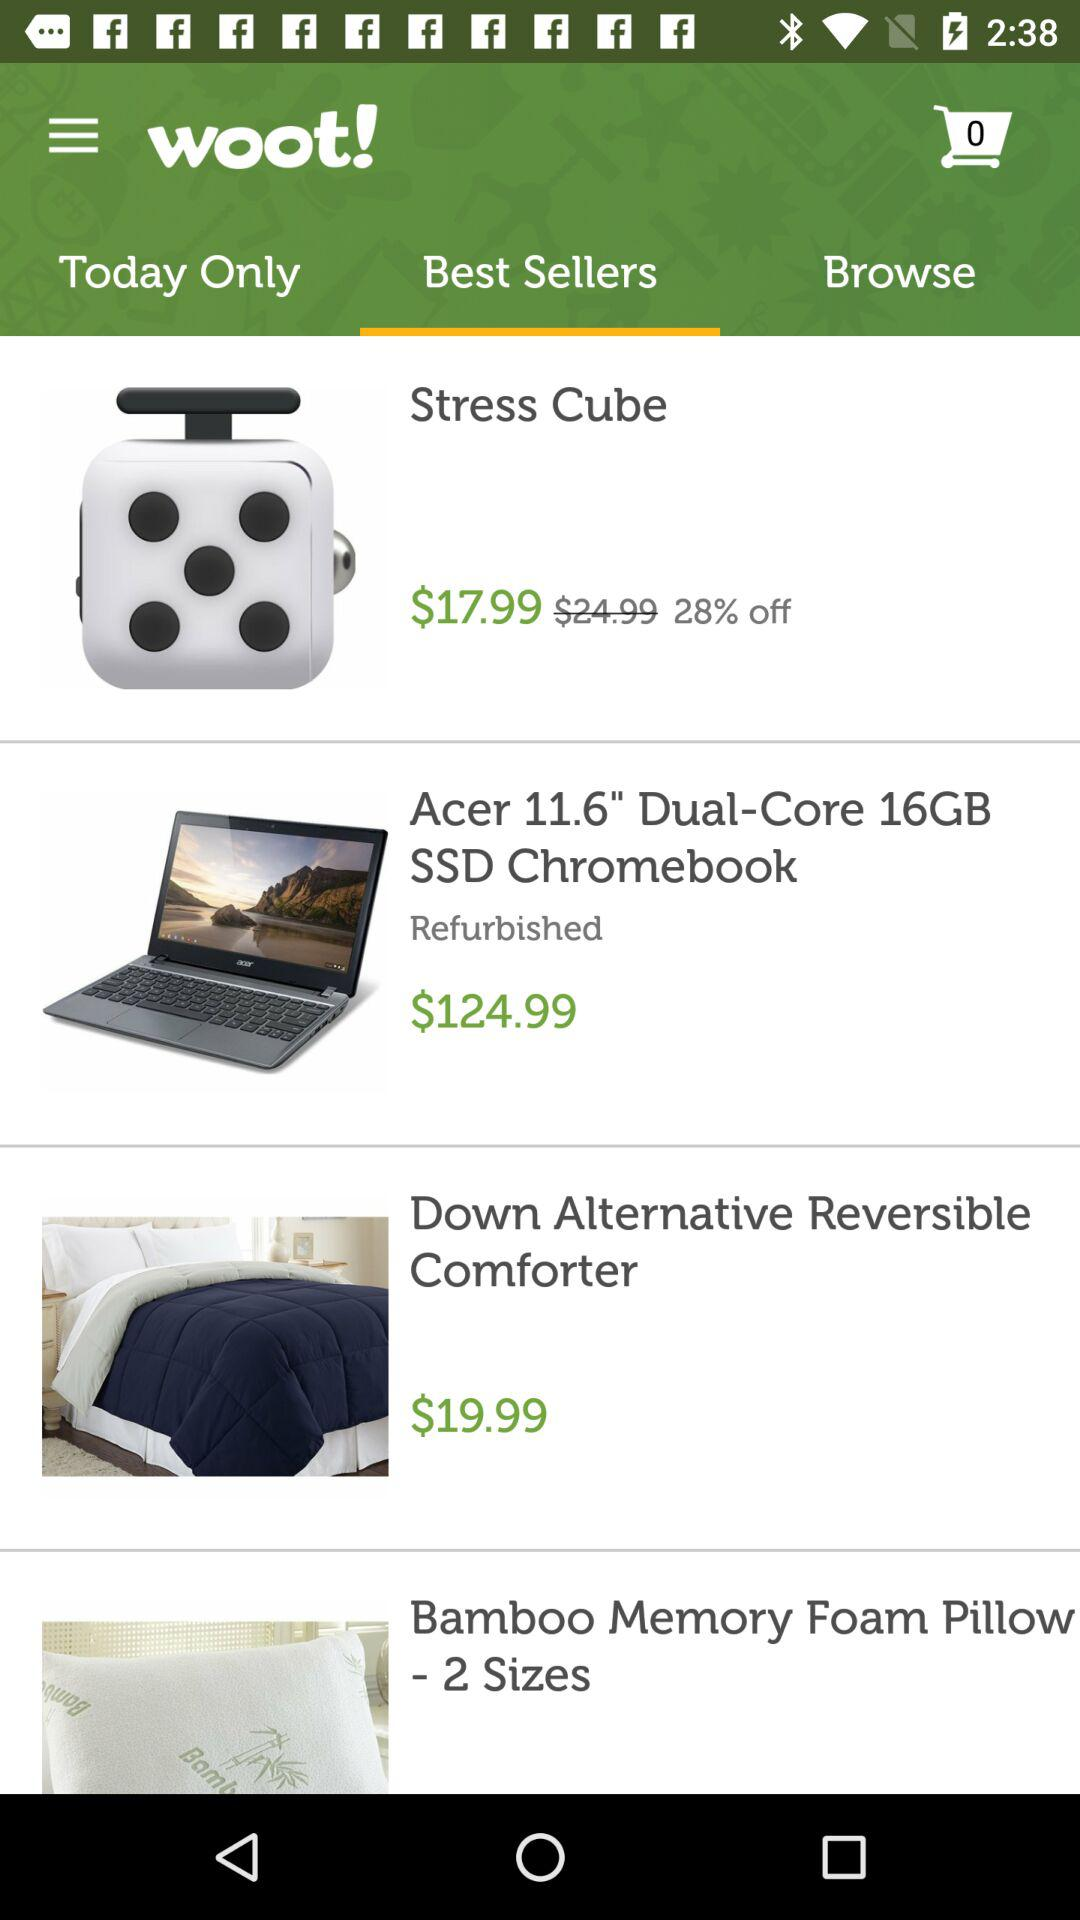Which items are available only for today?
When the provided information is insufficient, respond with <no answer>. <no answer> 